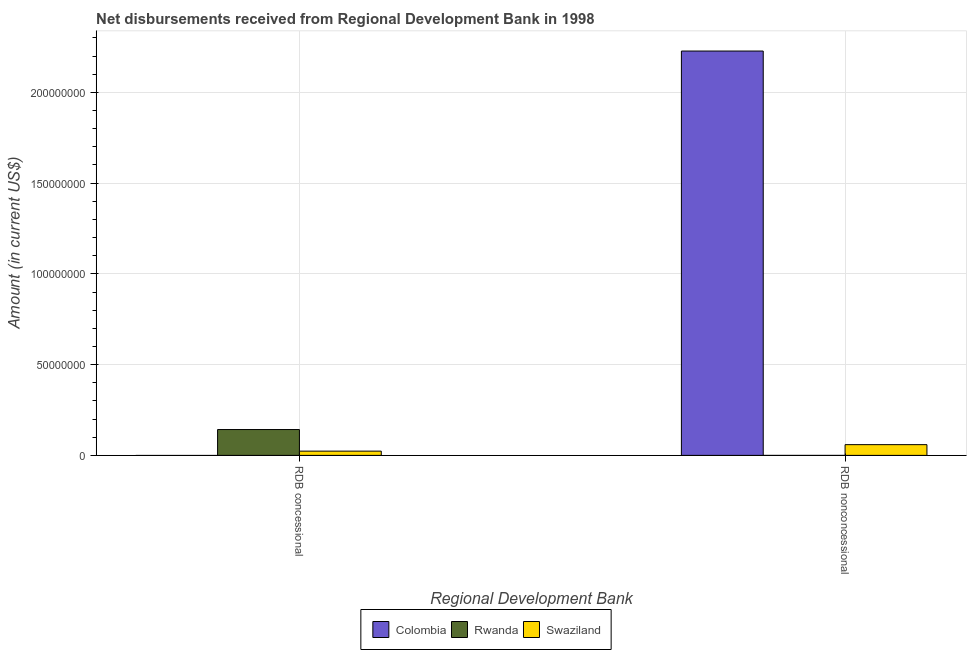How many different coloured bars are there?
Keep it short and to the point. 3. How many groups of bars are there?
Your answer should be very brief. 2. Are the number of bars per tick equal to the number of legend labels?
Your answer should be very brief. No. What is the label of the 1st group of bars from the left?
Provide a short and direct response. RDB concessional. What is the net concessional disbursements from rdb in Colombia?
Offer a very short reply. 0. Across all countries, what is the maximum net concessional disbursements from rdb?
Your answer should be compact. 1.42e+07. What is the total net concessional disbursements from rdb in the graph?
Give a very brief answer. 1.66e+07. What is the difference between the net concessional disbursements from rdb in Rwanda and that in Swaziland?
Offer a terse response. 1.19e+07. What is the difference between the net concessional disbursements from rdb in Swaziland and the net non concessional disbursements from rdb in Colombia?
Offer a very short reply. -2.20e+08. What is the average net concessional disbursements from rdb per country?
Give a very brief answer. 5.53e+06. What is the difference between the net concessional disbursements from rdb and net non concessional disbursements from rdb in Swaziland?
Your answer should be very brief. -3.57e+06. In how many countries, is the net concessional disbursements from rdb greater than the average net concessional disbursements from rdb taken over all countries?
Your answer should be compact. 1. How many bars are there?
Ensure brevity in your answer.  4. How many countries are there in the graph?
Give a very brief answer. 3. What is the difference between two consecutive major ticks on the Y-axis?
Your response must be concise. 5.00e+07. Are the values on the major ticks of Y-axis written in scientific E-notation?
Offer a terse response. No. Where does the legend appear in the graph?
Give a very brief answer. Bottom center. How many legend labels are there?
Your response must be concise. 3. What is the title of the graph?
Your answer should be compact. Net disbursements received from Regional Development Bank in 1998. What is the label or title of the X-axis?
Make the answer very short. Regional Development Bank. What is the Amount (in current US$) in Colombia in RDB concessional?
Keep it short and to the point. 0. What is the Amount (in current US$) of Rwanda in RDB concessional?
Your answer should be very brief. 1.42e+07. What is the Amount (in current US$) of Swaziland in RDB concessional?
Your answer should be very brief. 2.34e+06. What is the Amount (in current US$) in Colombia in RDB nonconcessional?
Your answer should be compact. 2.23e+08. What is the Amount (in current US$) of Swaziland in RDB nonconcessional?
Provide a short and direct response. 5.92e+06. Across all Regional Development Bank, what is the maximum Amount (in current US$) of Colombia?
Your response must be concise. 2.23e+08. Across all Regional Development Bank, what is the maximum Amount (in current US$) of Rwanda?
Keep it short and to the point. 1.42e+07. Across all Regional Development Bank, what is the maximum Amount (in current US$) in Swaziland?
Your response must be concise. 5.92e+06. Across all Regional Development Bank, what is the minimum Amount (in current US$) of Colombia?
Ensure brevity in your answer.  0. Across all Regional Development Bank, what is the minimum Amount (in current US$) of Rwanda?
Your response must be concise. 0. Across all Regional Development Bank, what is the minimum Amount (in current US$) of Swaziland?
Offer a terse response. 2.34e+06. What is the total Amount (in current US$) of Colombia in the graph?
Ensure brevity in your answer.  2.23e+08. What is the total Amount (in current US$) in Rwanda in the graph?
Offer a very short reply. 1.42e+07. What is the total Amount (in current US$) in Swaziland in the graph?
Offer a very short reply. 8.26e+06. What is the difference between the Amount (in current US$) of Swaziland in RDB concessional and that in RDB nonconcessional?
Your answer should be very brief. -3.57e+06. What is the difference between the Amount (in current US$) of Rwanda in RDB concessional and the Amount (in current US$) of Swaziland in RDB nonconcessional?
Offer a terse response. 8.32e+06. What is the average Amount (in current US$) in Colombia per Regional Development Bank?
Make the answer very short. 1.11e+08. What is the average Amount (in current US$) of Rwanda per Regional Development Bank?
Make the answer very short. 7.12e+06. What is the average Amount (in current US$) in Swaziland per Regional Development Bank?
Provide a short and direct response. 4.13e+06. What is the difference between the Amount (in current US$) in Rwanda and Amount (in current US$) in Swaziland in RDB concessional?
Ensure brevity in your answer.  1.19e+07. What is the difference between the Amount (in current US$) in Colombia and Amount (in current US$) in Swaziland in RDB nonconcessional?
Offer a very short reply. 2.17e+08. What is the ratio of the Amount (in current US$) of Swaziland in RDB concessional to that in RDB nonconcessional?
Provide a succinct answer. 0.4. What is the difference between the highest and the second highest Amount (in current US$) in Swaziland?
Provide a short and direct response. 3.57e+06. What is the difference between the highest and the lowest Amount (in current US$) of Colombia?
Give a very brief answer. 2.23e+08. What is the difference between the highest and the lowest Amount (in current US$) of Rwanda?
Provide a succinct answer. 1.42e+07. What is the difference between the highest and the lowest Amount (in current US$) in Swaziland?
Offer a very short reply. 3.57e+06. 